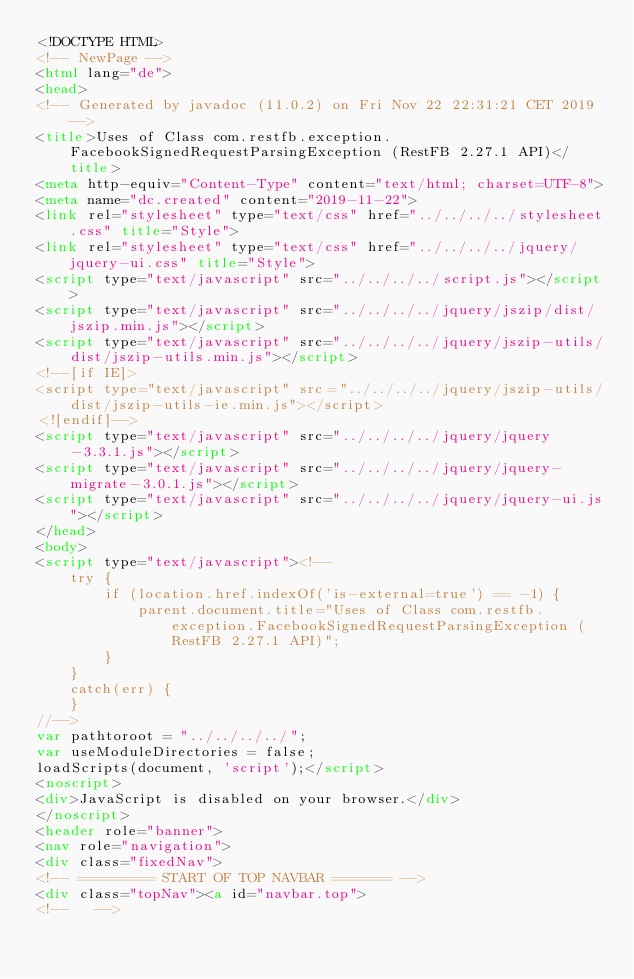Convert code to text. <code><loc_0><loc_0><loc_500><loc_500><_HTML_><!DOCTYPE HTML>
<!-- NewPage -->
<html lang="de">
<head>
<!-- Generated by javadoc (11.0.2) on Fri Nov 22 22:31:21 CET 2019 -->
<title>Uses of Class com.restfb.exception.FacebookSignedRequestParsingException (RestFB 2.27.1 API)</title>
<meta http-equiv="Content-Type" content="text/html; charset=UTF-8">
<meta name="dc.created" content="2019-11-22">
<link rel="stylesheet" type="text/css" href="../../../../stylesheet.css" title="Style">
<link rel="stylesheet" type="text/css" href="../../../../jquery/jquery-ui.css" title="Style">
<script type="text/javascript" src="../../../../script.js"></script>
<script type="text/javascript" src="../../../../jquery/jszip/dist/jszip.min.js"></script>
<script type="text/javascript" src="../../../../jquery/jszip-utils/dist/jszip-utils.min.js"></script>
<!--[if IE]>
<script type="text/javascript" src="../../../../jquery/jszip-utils/dist/jszip-utils-ie.min.js"></script>
<![endif]-->
<script type="text/javascript" src="../../../../jquery/jquery-3.3.1.js"></script>
<script type="text/javascript" src="../../../../jquery/jquery-migrate-3.0.1.js"></script>
<script type="text/javascript" src="../../../../jquery/jquery-ui.js"></script>
</head>
<body>
<script type="text/javascript"><!--
    try {
        if (location.href.indexOf('is-external=true') == -1) {
            parent.document.title="Uses of Class com.restfb.exception.FacebookSignedRequestParsingException (RestFB 2.27.1 API)";
        }
    }
    catch(err) {
    }
//-->
var pathtoroot = "../../../../";
var useModuleDirectories = false;
loadScripts(document, 'script');</script>
<noscript>
<div>JavaScript is disabled on your browser.</div>
</noscript>
<header role="banner">
<nav role="navigation">
<div class="fixedNav">
<!-- ========= START OF TOP NAVBAR ======= -->
<div class="topNav"><a id="navbar.top">
<!--   --></code> 